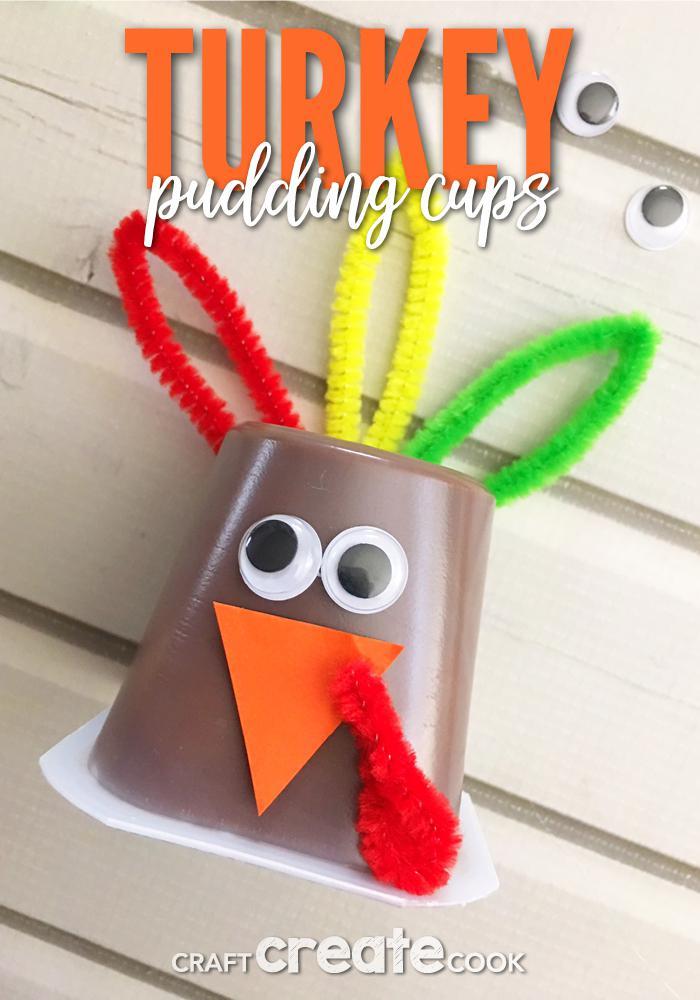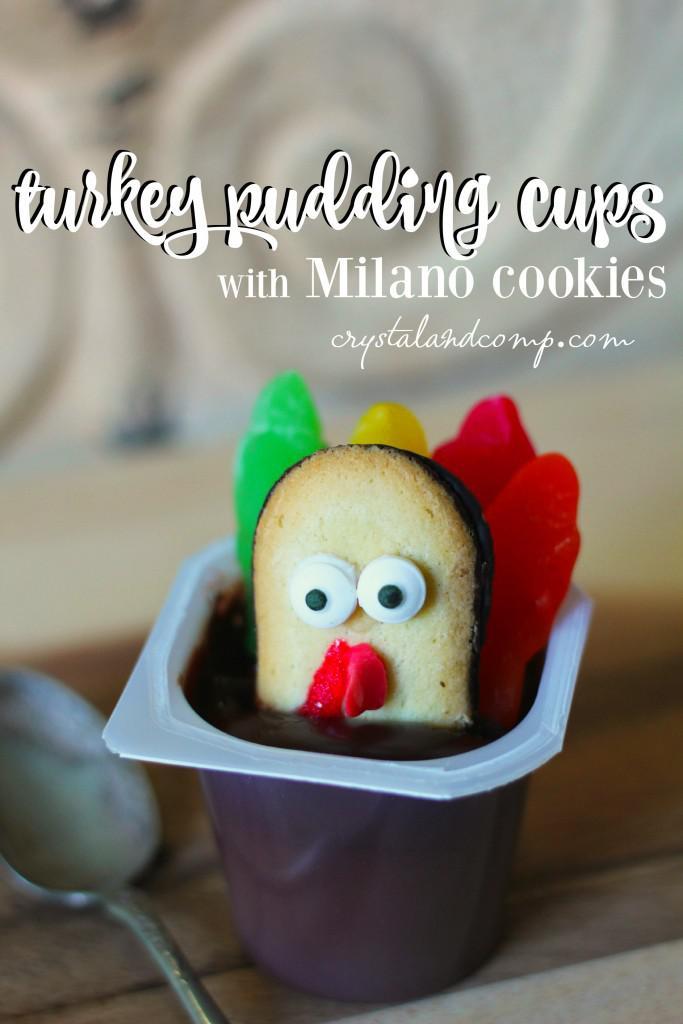The first image is the image on the left, the second image is the image on the right. Given the left and right images, does the statement "The left and right image contains a total of four pudding cups with turkey faces." hold true? Answer yes or no. No. The first image is the image on the left, the second image is the image on the right. Examine the images to the left and right. Is the description "One image shows three pudding cup 'turkeys' that are not in a single row, and the other image includes an inverted pudding cup with a turkey face and feathers." accurate? Answer yes or no. No. 